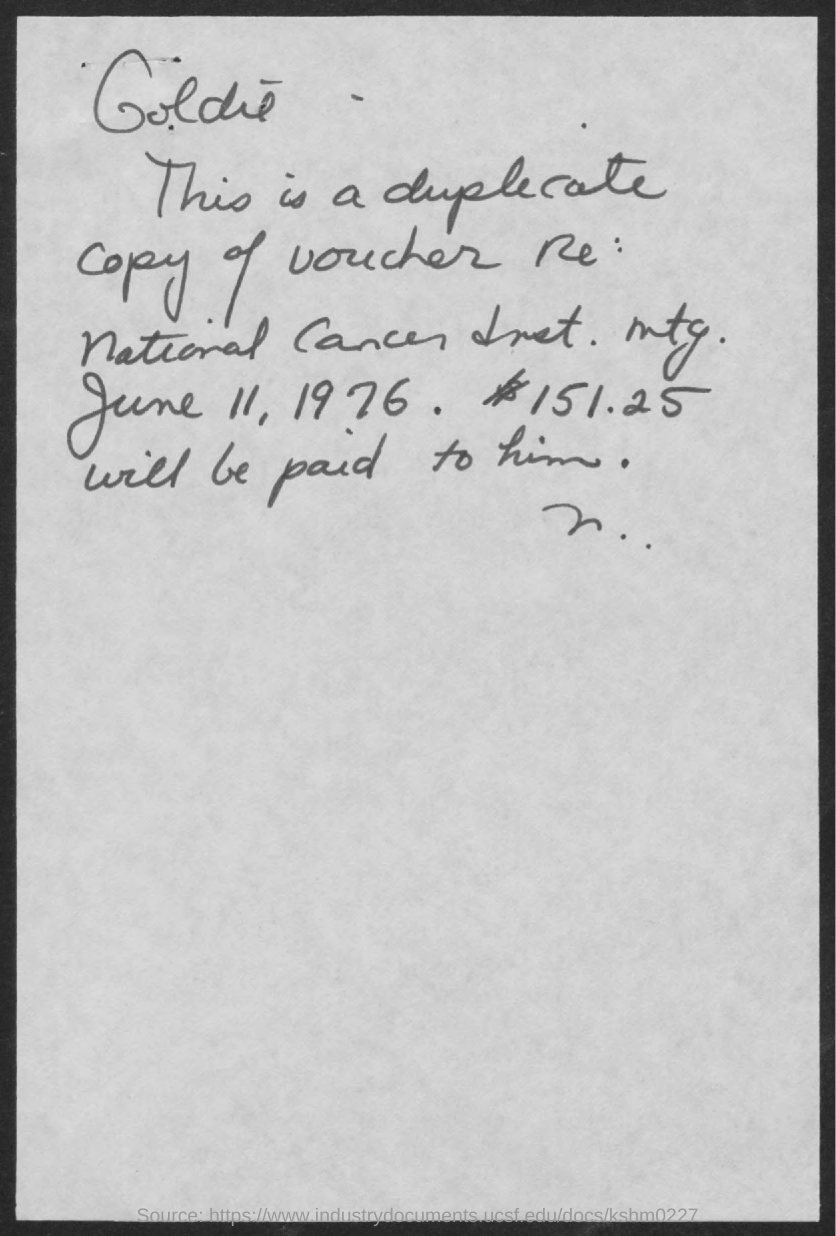List a handful of essential elements in this visual. The amount mentioned in the given form is 151.25... The date mentioned on the given page is June 11, 1976. 